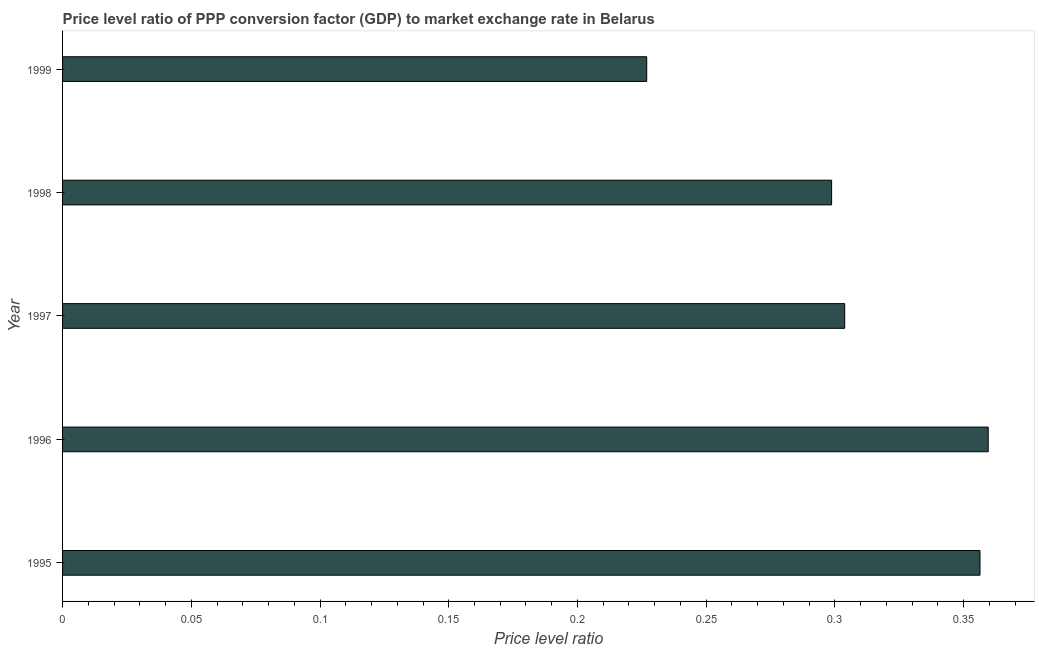Does the graph contain grids?
Provide a short and direct response. No. What is the title of the graph?
Provide a succinct answer. Price level ratio of PPP conversion factor (GDP) to market exchange rate in Belarus. What is the label or title of the X-axis?
Keep it short and to the point. Price level ratio. What is the label or title of the Y-axis?
Give a very brief answer. Year. What is the price level ratio in 1996?
Provide a short and direct response. 0.36. Across all years, what is the maximum price level ratio?
Make the answer very short. 0.36. Across all years, what is the minimum price level ratio?
Your answer should be compact. 0.23. In which year was the price level ratio maximum?
Offer a very short reply. 1996. What is the sum of the price level ratio?
Provide a short and direct response. 1.55. What is the difference between the price level ratio in 1996 and 1998?
Ensure brevity in your answer.  0.06. What is the average price level ratio per year?
Keep it short and to the point. 0.31. What is the median price level ratio?
Provide a succinct answer. 0.3. What is the ratio of the price level ratio in 1995 to that in 1999?
Provide a succinct answer. 1.57. Is the price level ratio in 1996 less than that in 1998?
Ensure brevity in your answer.  No. Is the difference between the price level ratio in 1995 and 1999 greater than the difference between any two years?
Make the answer very short. No. What is the difference between the highest and the second highest price level ratio?
Provide a short and direct response. 0. What is the difference between the highest and the lowest price level ratio?
Give a very brief answer. 0.13. Are all the bars in the graph horizontal?
Offer a terse response. Yes. What is the difference between two consecutive major ticks on the X-axis?
Ensure brevity in your answer.  0.05. What is the Price level ratio in 1995?
Your answer should be very brief. 0.36. What is the Price level ratio in 1996?
Your answer should be compact. 0.36. What is the Price level ratio of 1997?
Make the answer very short. 0.3. What is the Price level ratio in 1998?
Provide a succinct answer. 0.3. What is the Price level ratio of 1999?
Give a very brief answer. 0.23. What is the difference between the Price level ratio in 1995 and 1996?
Make the answer very short. -0. What is the difference between the Price level ratio in 1995 and 1997?
Ensure brevity in your answer.  0.05. What is the difference between the Price level ratio in 1995 and 1998?
Make the answer very short. 0.06. What is the difference between the Price level ratio in 1995 and 1999?
Your answer should be compact. 0.13. What is the difference between the Price level ratio in 1996 and 1997?
Offer a very short reply. 0.06. What is the difference between the Price level ratio in 1996 and 1998?
Offer a terse response. 0.06. What is the difference between the Price level ratio in 1996 and 1999?
Your response must be concise. 0.13. What is the difference between the Price level ratio in 1997 and 1998?
Provide a short and direct response. 0.01. What is the difference between the Price level ratio in 1997 and 1999?
Provide a succinct answer. 0.08. What is the difference between the Price level ratio in 1998 and 1999?
Ensure brevity in your answer.  0.07. What is the ratio of the Price level ratio in 1995 to that in 1996?
Keep it short and to the point. 0.99. What is the ratio of the Price level ratio in 1995 to that in 1997?
Your answer should be compact. 1.17. What is the ratio of the Price level ratio in 1995 to that in 1998?
Ensure brevity in your answer.  1.19. What is the ratio of the Price level ratio in 1995 to that in 1999?
Make the answer very short. 1.57. What is the ratio of the Price level ratio in 1996 to that in 1997?
Your answer should be very brief. 1.18. What is the ratio of the Price level ratio in 1996 to that in 1998?
Keep it short and to the point. 1.2. What is the ratio of the Price level ratio in 1996 to that in 1999?
Your response must be concise. 1.58. What is the ratio of the Price level ratio in 1997 to that in 1998?
Your response must be concise. 1.02. What is the ratio of the Price level ratio in 1997 to that in 1999?
Keep it short and to the point. 1.34. What is the ratio of the Price level ratio in 1998 to that in 1999?
Your answer should be very brief. 1.32. 